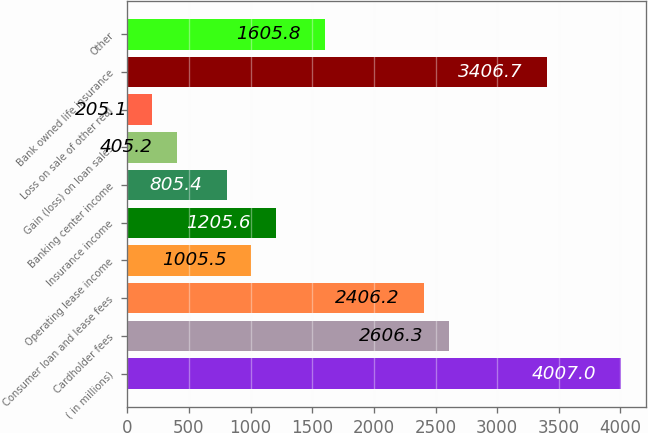<chart> <loc_0><loc_0><loc_500><loc_500><bar_chart><fcel>( in millions)<fcel>Cardholder fees<fcel>Consumer loan and lease fees<fcel>Operating lease income<fcel>Insurance income<fcel>Banking center income<fcel>Gain (loss) on loan sales<fcel>Loss on sale of other real<fcel>Bank owned life insurance<fcel>Other<nl><fcel>4007<fcel>2606.3<fcel>2406.2<fcel>1005.5<fcel>1205.6<fcel>805.4<fcel>405.2<fcel>205.1<fcel>3406.7<fcel>1605.8<nl></chart> 